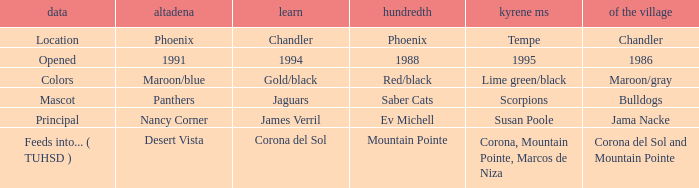What kind of Altadeña has del Pueblo of maroon/gray? Maroon/blue. 